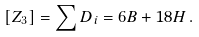Convert formula to latex. <formula><loc_0><loc_0><loc_500><loc_500>[ Z _ { 3 } ] = \sum D _ { i } = 6 B + 1 8 H \, .</formula> 